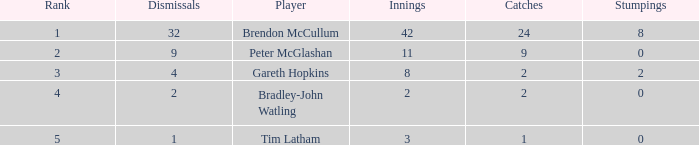Enumerate the positions of all 4-point dismissals. 3.0. 